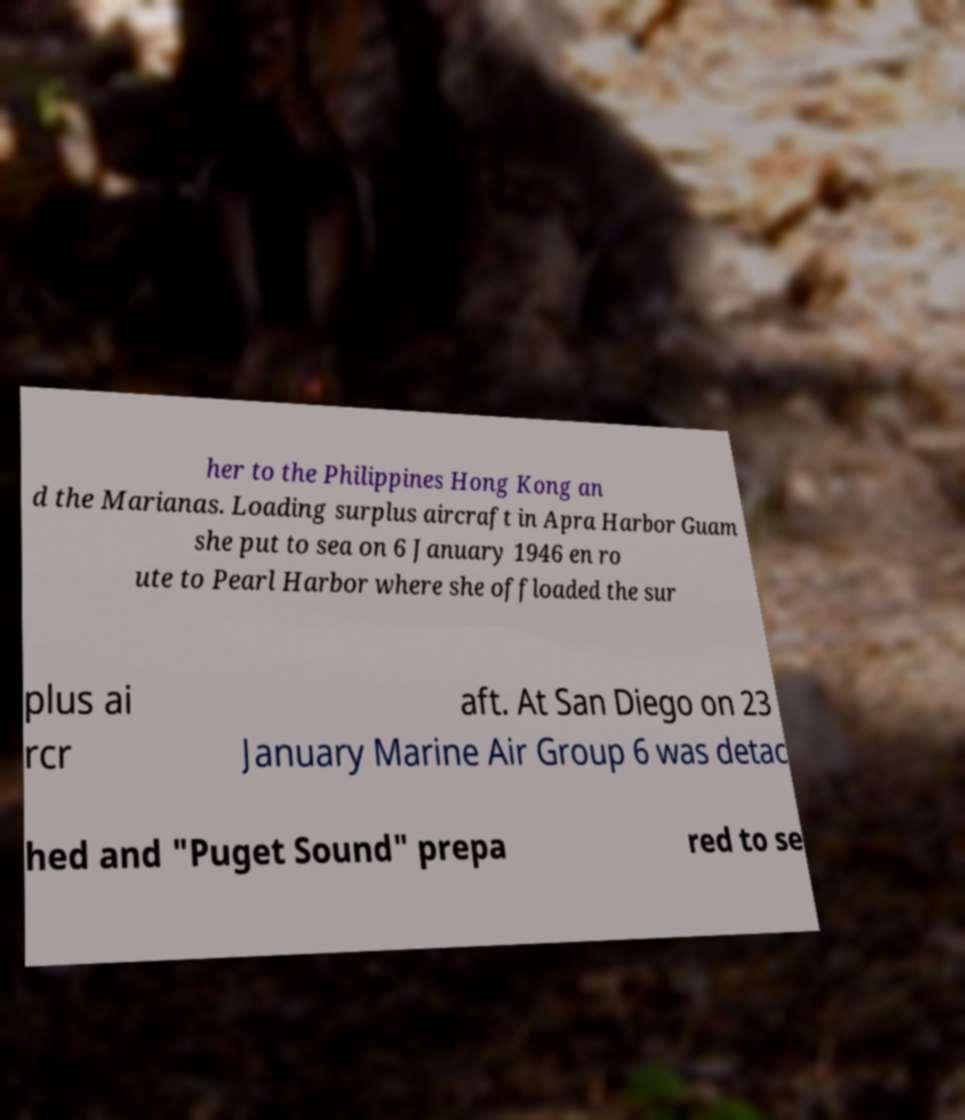What messages or text are displayed in this image? I need them in a readable, typed format. her to the Philippines Hong Kong an d the Marianas. Loading surplus aircraft in Apra Harbor Guam she put to sea on 6 January 1946 en ro ute to Pearl Harbor where she offloaded the sur plus ai rcr aft. At San Diego on 23 January Marine Air Group 6 was detac hed and "Puget Sound" prepa red to se 